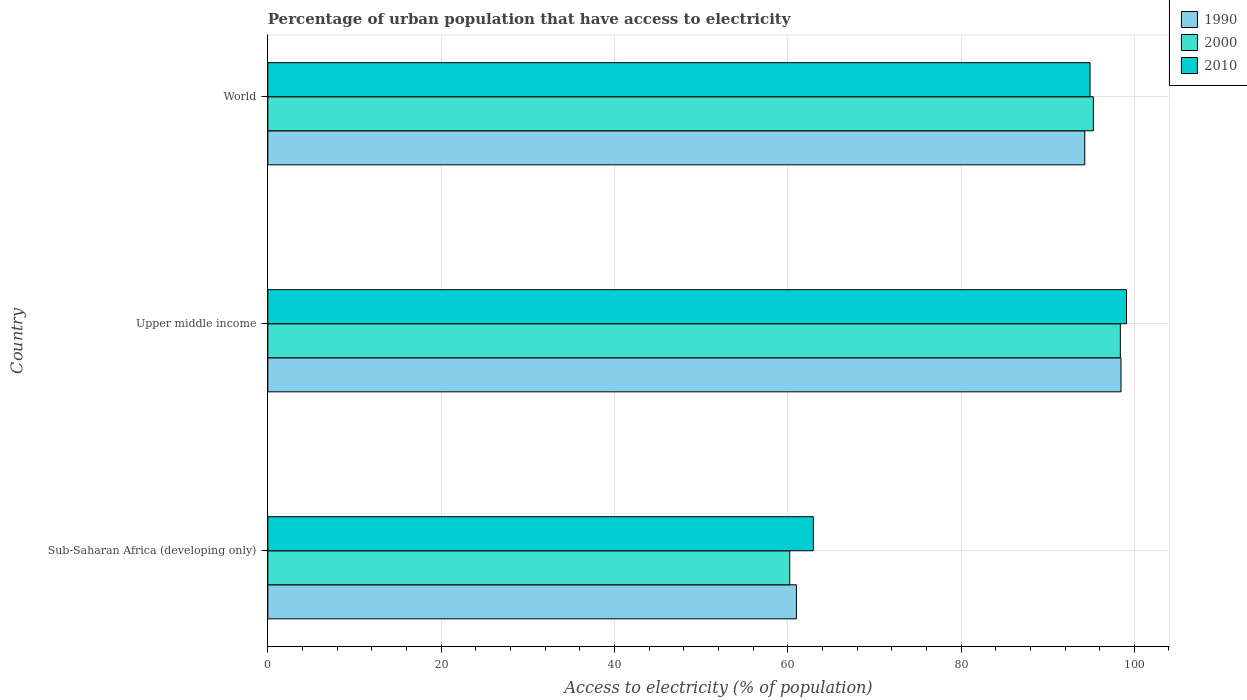Are the number of bars on each tick of the Y-axis equal?
Offer a very short reply. Yes. How many bars are there on the 2nd tick from the bottom?
Make the answer very short. 3. What is the label of the 2nd group of bars from the top?
Provide a succinct answer. Upper middle income. What is the percentage of urban population that have access to electricity in 2000 in Upper middle income?
Keep it short and to the point. 98.39. Across all countries, what is the maximum percentage of urban population that have access to electricity in 2010?
Make the answer very short. 99.1. Across all countries, what is the minimum percentage of urban population that have access to electricity in 2000?
Offer a terse response. 60.23. In which country was the percentage of urban population that have access to electricity in 2000 maximum?
Keep it short and to the point. Upper middle income. In which country was the percentage of urban population that have access to electricity in 2000 minimum?
Offer a terse response. Sub-Saharan Africa (developing only). What is the total percentage of urban population that have access to electricity in 2000 in the graph?
Keep it short and to the point. 253.89. What is the difference between the percentage of urban population that have access to electricity in 1990 in Sub-Saharan Africa (developing only) and that in Upper middle income?
Keep it short and to the point. -37.46. What is the difference between the percentage of urban population that have access to electricity in 2000 in Upper middle income and the percentage of urban population that have access to electricity in 1990 in World?
Your answer should be very brief. 4.11. What is the average percentage of urban population that have access to electricity in 1990 per country?
Ensure brevity in your answer.  84.58. What is the difference between the percentage of urban population that have access to electricity in 2000 and percentage of urban population that have access to electricity in 2010 in Sub-Saharan Africa (developing only)?
Provide a succinct answer. -2.73. In how many countries, is the percentage of urban population that have access to electricity in 2000 greater than 20 %?
Keep it short and to the point. 3. What is the ratio of the percentage of urban population that have access to electricity in 2000 in Sub-Saharan Africa (developing only) to that in Upper middle income?
Provide a succinct answer. 0.61. Is the percentage of urban population that have access to electricity in 1990 in Sub-Saharan Africa (developing only) less than that in Upper middle income?
Keep it short and to the point. Yes. Is the difference between the percentage of urban population that have access to electricity in 2000 in Upper middle income and World greater than the difference between the percentage of urban population that have access to electricity in 2010 in Upper middle income and World?
Your answer should be very brief. No. What is the difference between the highest and the second highest percentage of urban population that have access to electricity in 1990?
Your answer should be very brief. 4.19. What is the difference between the highest and the lowest percentage of urban population that have access to electricity in 1990?
Provide a short and direct response. 37.46. Is the sum of the percentage of urban population that have access to electricity in 2010 in Sub-Saharan Africa (developing only) and Upper middle income greater than the maximum percentage of urban population that have access to electricity in 1990 across all countries?
Ensure brevity in your answer.  Yes. How many bars are there?
Offer a terse response. 9. Are all the bars in the graph horizontal?
Make the answer very short. Yes. What is the difference between two consecutive major ticks on the X-axis?
Provide a short and direct response. 20. Does the graph contain any zero values?
Make the answer very short. No. Where does the legend appear in the graph?
Provide a short and direct response. Top right. What is the title of the graph?
Provide a short and direct response. Percentage of urban population that have access to electricity. Does "1960" appear as one of the legend labels in the graph?
Provide a short and direct response. No. What is the label or title of the X-axis?
Keep it short and to the point. Access to electricity (% of population). What is the label or title of the Y-axis?
Provide a short and direct response. Country. What is the Access to electricity (% of population) of 1990 in Sub-Saharan Africa (developing only)?
Offer a very short reply. 61.01. What is the Access to electricity (% of population) in 2000 in Sub-Saharan Africa (developing only)?
Offer a very short reply. 60.23. What is the Access to electricity (% of population) in 2010 in Sub-Saharan Africa (developing only)?
Offer a terse response. 62.95. What is the Access to electricity (% of population) of 1990 in Upper middle income?
Your response must be concise. 98.47. What is the Access to electricity (% of population) in 2000 in Upper middle income?
Your answer should be compact. 98.39. What is the Access to electricity (% of population) in 2010 in Upper middle income?
Your response must be concise. 99.1. What is the Access to electricity (% of population) in 1990 in World?
Provide a short and direct response. 94.28. What is the Access to electricity (% of population) in 2000 in World?
Ensure brevity in your answer.  95.27. What is the Access to electricity (% of population) in 2010 in World?
Ensure brevity in your answer.  94.89. Across all countries, what is the maximum Access to electricity (% of population) of 1990?
Offer a terse response. 98.47. Across all countries, what is the maximum Access to electricity (% of population) in 2000?
Ensure brevity in your answer.  98.39. Across all countries, what is the maximum Access to electricity (% of population) of 2010?
Provide a succinct answer. 99.1. Across all countries, what is the minimum Access to electricity (% of population) of 1990?
Give a very brief answer. 61.01. Across all countries, what is the minimum Access to electricity (% of population) of 2000?
Ensure brevity in your answer.  60.23. Across all countries, what is the minimum Access to electricity (% of population) in 2010?
Ensure brevity in your answer.  62.95. What is the total Access to electricity (% of population) of 1990 in the graph?
Offer a very short reply. 253.75. What is the total Access to electricity (% of population) of 2000 in the graph?
Provide a succinct answer. 253.89. What is the total Access to electricity (% of population) of 2010 in the graph?
Provide a short and direct response. 256.94. What is the difference between the Access to electricity (% of population) in 1990 in Sub-Saharan Africa (developing only) and that in Upper middle income?
Your answer should be compact. -37.46. What is the difference between the Access to electricity (% of population) of 2000 in Sub-Saharan Africa (developing only) and that in Upper middle income?
Make the answer very short. -38.16. What is the difference between the Access to electricity (% of population) of 2010 in Sub-Saharan Africa (developing only) and that in Upper middle income?
Ensure brevity in your answer.  -36.14. What is the difference between the Access to electricity (% of population) of 1990 in Sub-Saharan Africa (developing only) and that in World?
Your answer should be compact. -33.27. What is the difference between the Access to electricity (% of population) in 2000 in Sub-Saharan Africa (developing only) and that in World?
Provide a short and direct response. -35.04. What is the difference between the Access to electricity (% of population) in 2010 in Sub-Saharan Africa (developing only) and that in World?
Your answer should be very brief. -31.94. What is the difference between the Access to electricity (% of population) in 1990 in Upper middle income and that in World?
Ensure brevity in your answer.  4.19. What is the difference between the Access to electricity (% of population) in 2000 in Upper middle income and that in World?
Your response must be concise. 3.12. What is the difference between the Access to electricity (% of population) in 2010 in Upper middle income and that in World?
Provide a short and direct response. 4.21. What is the difference between the Access to electricity (% of population) in 1990 in Sub-Saharan Africa (developing only) and the Access to electricity (% of population) in 2000 in Upper middle income?
Make the answer very short. -37.38. What is the difference between the Access to electricity (% of population) in 1990 in Sub-Saharan Africa (developing only) and the Access to electricity (% of population) in 2010 in Upper middle income?
Ensure brevity in your answer.  -38.09. What is the difference between the Access to electricity (% of population) of 2000 in Sub-Saharan Africa (developing only) and the Access to electricity (% of population) of 2010 in Upper middle income?
Your response must be concise. -38.87. What is the difference between the Access to electricity (% of population) of 1990 in Sub-Saharan Africa (developing only) and the Access to electricity (% of population) of 2000 in World?
Provide a succinct answer. -34.26. What is the difference between the Access to electricity (% of population) in 1990 in Sub-Saharan Africa (developing only) and the Access to electricity (% of population) in 2010 in World?
Provide a short and direct response. -33.88. What is the difference between the Access to electricity (% of population) of 2000 in Sub-Saharan Africa (developing only) and the Access to electricity (% of population) of 2010 in World?
Ensure brevity in your answer.  -34.66. What is the difference between the Access to electricity (% of population) in 1990 in Upper middle income and the Access to electricity (% of population) in 2000 in World?
Your answer should be compact. 3.2. What is the difference between the Access to electricity (% of population) of 1990 in Upper middle income and the Access to electricity (% of population) of 2010 in World?
Make the answer very short. 3.57. What is the difference between the Access to electricity (% of population) of 2000 in Upper middle income and the Access to electricity (% of population) of 2010 in World?
Make the answer very short. 3.5. What is the average Access to electricity (% of population) of 1990 per country?
Ensure brevity in your answer.  84.58. What is the average Access to electricity (% of population) in 2000 per country?
Provide a short and direct response. 84.63. What is the average Access to electricity (% of population) in 2010 per country?
Offer a terse response. 85.65. What is the difference between the Access to electricity (% of population) of 1990 and Access to electricity (% of population) of 2000 in Sub-Saharan Africa (developing only)?
Offer a terse response. 0.78. What is the difference between the Access to electricity (% of population) in 1990 and Access to electricity (% of population) in 2010 in Sub-Saharan Africa (developing only)?
Your answer should be very brief. -1.95. What is the difference between the Access to electricity (% of population) of 2000 and Access to electricity (% of population) of 2010 in Sub-Saharan Africa (developing only)?
Ensure brevity in your answer.  -2.73. What is the difference between the Access to electricity (% of population) of 1990 and Access to electricity (% of population) of 2000 in Upper middle income?
Provide a succinct answer. 0.08. What is the difference between the Access to electricity (% of population) of 1990 and Access to electricity (% of population) of 2010 in Upper middle income?
Provide a succinct answer. -0.63. What is the difference between the Access to electricity (% of population) in 2000 and Access to electricity (% of population) in 2010 in Upper middle income?
Your answer should be very brief. -0.71. What is the difference between the Access to electricity (% of population) in 1990 and Access to electricity (% of population) in 2000 in World?
Your response must be concise. -0.99. What is the difference between the Access to electricity (% of population) of 1990 and Access to electricity (% of population) of 2010 in World?
Keep it short and to the point. -0.61. What is the difference between the Access to electricity (% of population) of 2000 and Access to electricity (% of population) of 2010 in World?
Ensure brevity in your answer.  0.38. What is the ratio of the Access to electricity (% of population) in 1990 in Sub-Saharan Africa (developing only) to that in Upper middle income?
Your answer should be very brief. 0.62. What is the ratio of the Access to electricity (% of population) of 2000 in Sub-Saharan Africa (developing only) to that in Upper middle income?
Give a very brief answer. 0.61. What is the ratio of the Access to electricity (% of population) of 2010 in Sub-Saharan Africa (developing only) to that in Upper middle income?
Your answer should be compact. 0.64. What is the ratio of the Access to electricity (% of population) in 1990 in Sub-Saharan Africa (developing only) to that in World?
Make the answer very short. 0.65. What is the ratio of the Access to electricity (% of population) of 2000 in Sub-Saharan Africa (developing only) to that in World?
Make the answer very short. 0.63. What is the ratio of the Access to electricity (% of population) in 2010 in Sub-Saharan Africa (developing only) to that in World?
Offer a very short reply. 0.66. What is the ratio of the Access to electricity (% of population) of 1990 in Upper middle income to that in World?
Provide a short and direct response. 1.04. What is the ratio of the Access to electricity (% of population) in 2000 in Upper middle income to that in World?
Provide a succinct answer. 1.03. What is the ratio of the Access to electricity (% of population) of 2010 in Upper middle income to that in World?
Provide a succinct answer. 1.04. What is the difference between the highest and the second highest Access to electricity (% of population) in 1990?
Offer a terse response. 4.19. What is the difference between the highest and the second highest Access to electricity (% of population) in 2000?
Offer a terse response. 3.12. What is the difference between the highest and the second highest Access to electricity (% of population) in 2010?
Offer a very short reply. 4.21. What is the difference between the highest and the lowest Access to electricity (% of population) in 1990?
Give a very brief answer. 37.46. What is the difference between the highest and the lowest Access to electricity (% of population) in 2000?
Your answer should be very brief. 38.16. What is the difference between the highest and the lowest Access to electricity (% of population) in 2010?
Offer a very short reply. 36.14. 